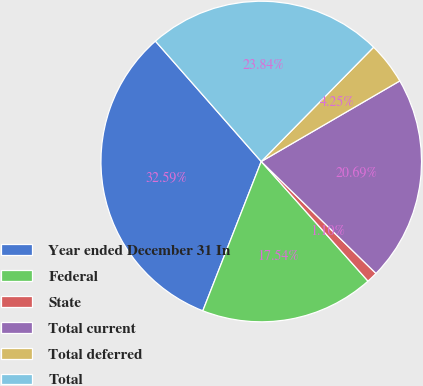Convert chart. <chart><loc_0><loc_0><loc_500><loc_500><pie_chart><fcel>Year ended December 31 In<fcel>Federal<fcel>State<fcel>Total current<fcel>Total deferred<fcel>Total<nl><fcel>32.59%<fcel>17.54%<fcel>1.1%<fcel>20.69%<fcel>4.25%<fcel>23.84%<nl></chart> 